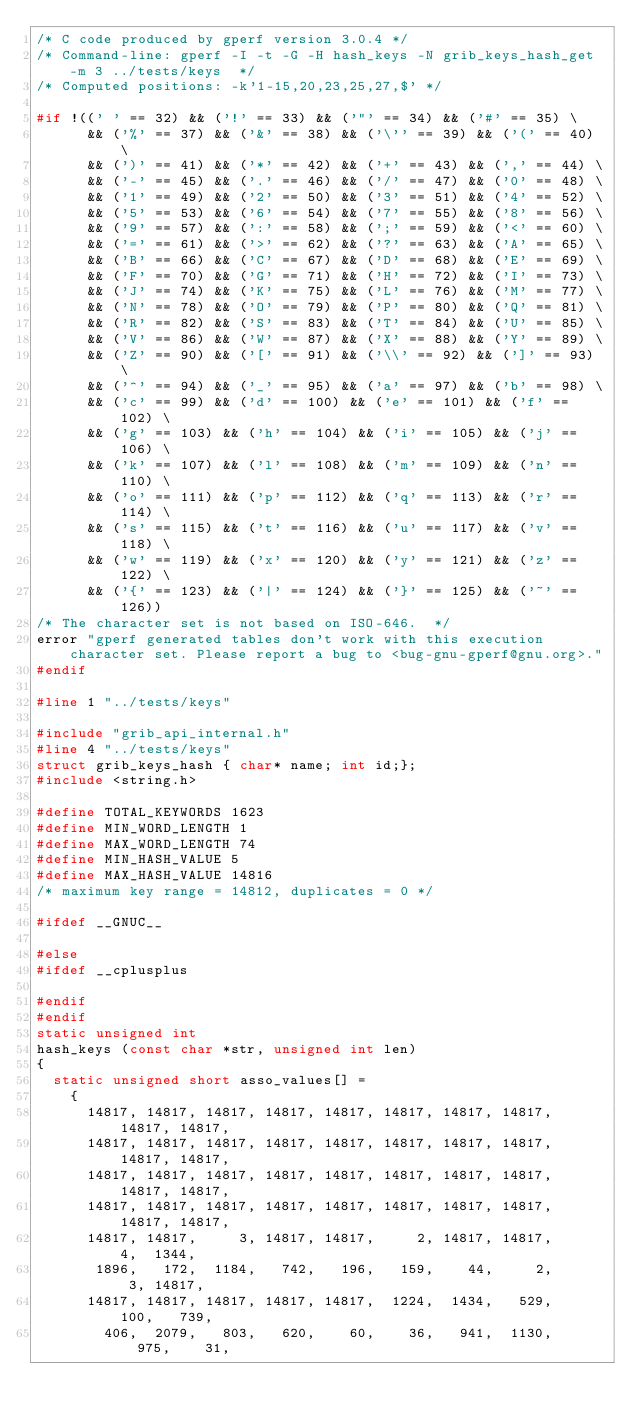<code> <loc_0><loc_0><loc_500><loc_500><_C_>/* C code produced by gperf version 3.0.4 */
/* Command-line: gperf -I -t -G -H hash_keys -N grib_keys_hash_get -m 3 ../tests/keys  */
/* Computed positions: -k'1-15,20,23,25,27,$' */

#if !((' ' == 32) && ('!' == 33) && ('"' == 34) && ('#' == 35) \
      && ('%' == 37) && ('&' == 38) && ('\'' == 39) && ('(' == 40) \
      && (')' == 41) && ('*' == 42) && ('+' == 43) && (',' == 44) \
      && ('-' == 45) && ('.' == 46) && ('/' == 47) && ('0' == 48) \
      && ('1' == 49) && ('2' == 50) && ('3' == 51) && ('4' == 52) \
      && ('5' == 53) && ('6' == 54) && ('7' == 55) && ('8' == 56) \
      && ('9' == 57) && (':' == 58) && (';' == 59) && ('<' == 60) \
      && ('=' == 61) && ('>' == 62) && ('?' == 63) && ('A' == 65) \
      && ('B' == 66) && ('C' == 67) && ('D' == 68) && ('E' == 69) \
      && ('F' == 70) && ('G' == 71) && ('H' == 72) && ('I' == 73) \
      && ('J' == 74) && ('K' == 75) && ('L' == 76) && ('M' == 77) \
      && ('N' == 78) && ('O' == 79) && ('P' == 80) && ('Q' == 81) \
      && ('R' == 82) && ('S' == 83) && ('T' == 84) && ('U' == 85) \
      && ('V' == 86) && ('W' == 87) && ('X' == 88) && ('Y' == 89) \
      && ('Z' == 90) && ('[' == 91) && ('\\' == 92) && (']' == 93) \
      && ('^' == 94) && ('_' == 95) && ('a' == 97) && ('b' == 98) \
      && ('c' == 99) && ('d' == 100) && ('e' == 101) && ('f' == 102) \
      && ('g' == 103) && ('h' == 104) && ('i' == 105) && ('j' == 106) \
      && ('k' == 107) && ('l' == 108) && ('m' == 109) && ('n' == 110) \
      && ('o' == 111) && ('p' == 112) && ('q' == 113) && ('r' == 114) \
      && ('s' == 115) && ('t' == 116) && ('u' == 117) && ('v' == 118) \
      && ('w' == 119) && ('x' == 120) && ('y' == 121) && ('z' == 122) \
      && ('{' == 123) && ('|' == 124) && ('}' == 125) && ('~' == 126))
/* The character set is not based on ISO-646.  */
error "gperf generated tables don't work with this execution character set. Please report a bug to <bug-gnu-gperf@gnu.org>."
#endif

#line 1 "../tests/keys"

#include "grib_api_internal.h"
#line 4 "../tests/keys"
struct grib_keys_hash { char* name; int id;};
#include <string.h>

#define TOTAL_KEYWORDS 1623
#define MIN_WORD_LENGTH 1
#define MAX_WORD_LENGTH 74
#define MIN_HASH_VALUE 5
#define MAX_HASH_VALUE 14816
/* maximum key range = 14812, duplicates = 0 */

#ifdef __GNUC__

#else
#ifdef __cplusplus

#endif
#endif
static unsigned int
hash_keys (const char *str, unsigned int len)
{
  static unsigned short asso_values[] =
    {
      14817, 14817, 14817, 14817, 14817, 14817, 14817, 14817, 14817, 14817,
      14817, 14817, 14817, 14817, 14817, 14817, 14817, 14817, 14817, 14817,
      14817, 14817, 14817, 14817, 14817, 14817, 14817, 14817, 14817, 14817,
      14817, 14817, 14817, 14817, 14817, 14817, 14817, 14817, 14817, 14817,
      14817, 14817,     3, 14817, 14817,     2, 14817, 14817,     4,  1344,
       1896,   172,  1184,   742,   196,   159,    44,     2,     3, 14817,
      14817, 14817, 14817, 14817, 14817,  1224,  1434,   529,   100,   739,
        406,  2079,   803,   620,    60,    36,   941,  1130,   975,    31,</code> 